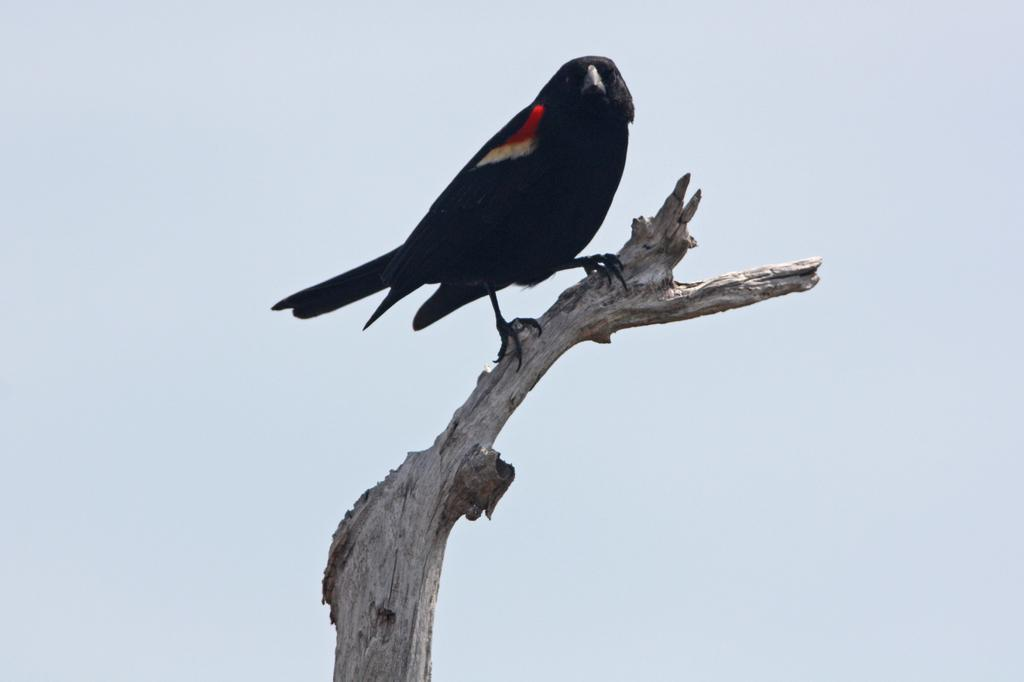What type of animal can be seen in the image? There is a bird in the image. Where is the bird located in the image? The bird is sitting on a stick. What can be seen in the background of the image? The sky is visible in the image. What type of hook is the bird using to fly in the image? There is no hook present in the image, and the bird is sitting on a stick, not flying. 